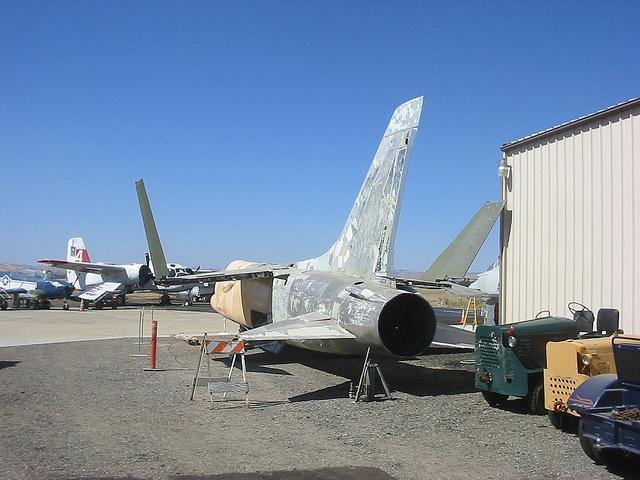How many airplanes can be seen?
Give a very brief answer. 3. 